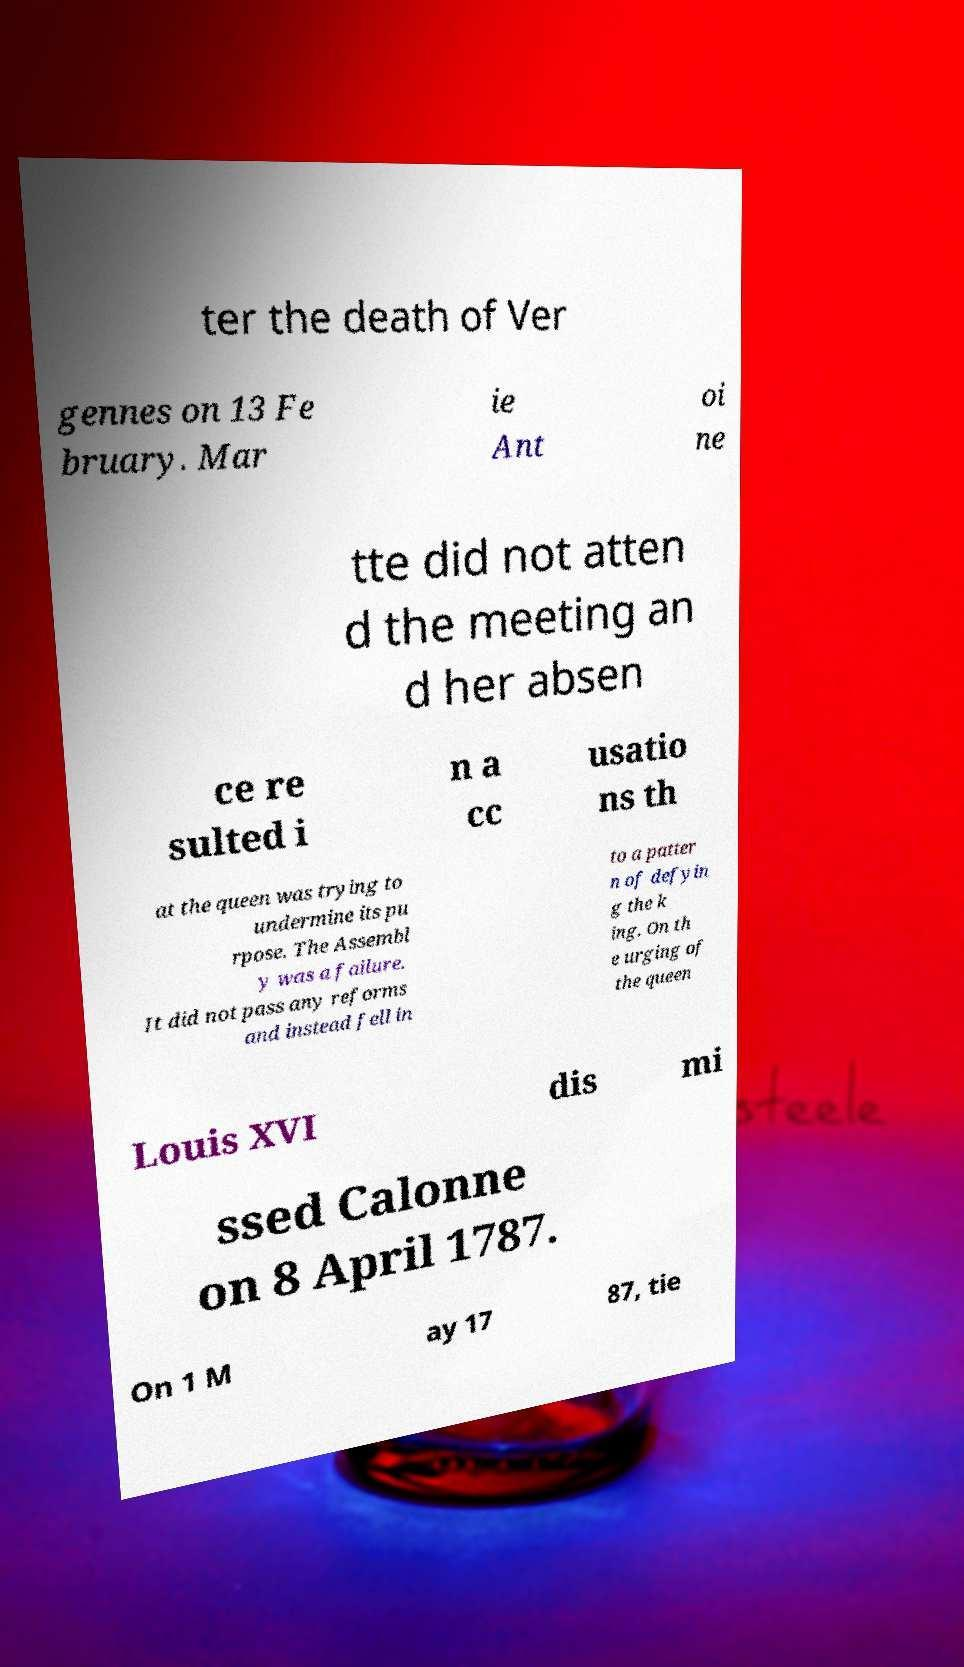I need the written content from this picture converted into text. Can you do that? ter the death of Ver gennes on 13 Fe bruary. Mar ie Ant oi ne tte did not atten d the meeting an d her absen ce re sulted i n a cc usatio ns th at the queen was trying to undermine its pu rpose. The Assembl y was a failure. It did not pass any reforms and instead fell in to a patter n of defyin g the k ing. On th e urging of the queen Louis XVI dis mi ssed Calonne on 8 April 1787. On 1 M ay 17 87, tie 